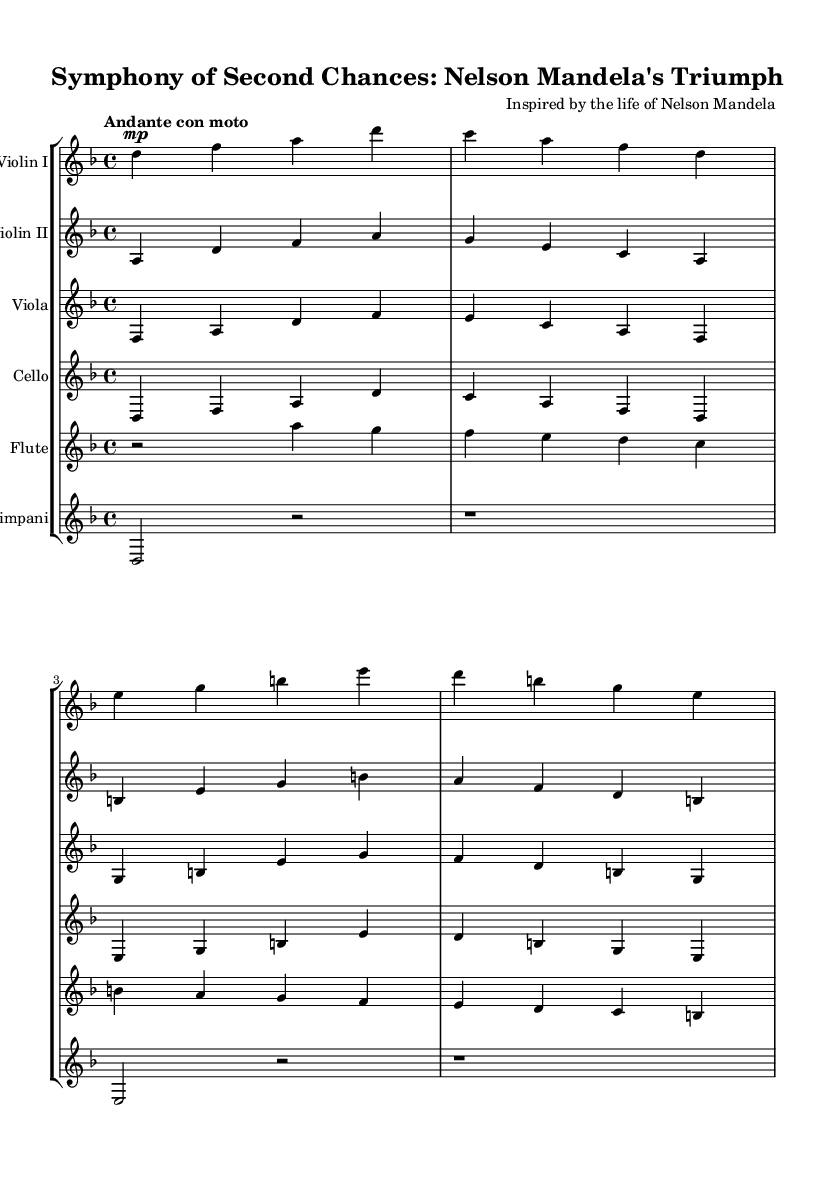What is the key signature of this symphony? The key signature shows two flats at the beginning, indicating that the composition is in D minor.
Answer: D minor What is the time signature of the piece? The time signature is shown as 4/4, meaning there are four beats in each measure and a quarter note receives one beat.
Answer: 4/4 What is the tempo marking of the symphony? The tempo marking is indicated as "Andante con moto," which suggests a moderately slow tempo with a sense of movement.
Answer: Andante con moto How many instruments are featured in this symphony? By counting the individual staffs, there are six distinct instruments indicated in the score: Violin I, Violin II, Viola, Cello, Flute, and Timpani.
Answer: Six Which instrument plays the melody in the first few measures? The Violin I part begins with the melody, indicating that it is the most prominent voice in those measures.
Answer: Violin I What dynamic marking is indicated for the Violin I part at the start? The score shows "mp" (mezzo-piano) as the dynamic marking, which instructs the performer to play moderately soft at the beginning.
Answer: mp 